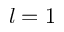<formula> <loc_0><loc_0><loc_500><loc_500>l = 1</formula> 